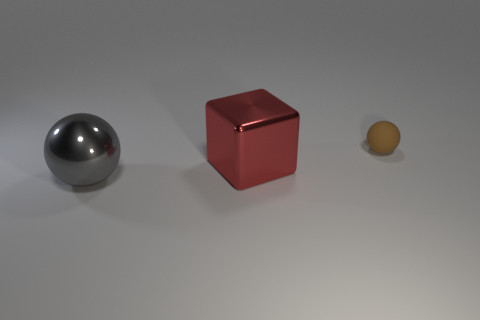Add 1 large cubes. How many objects exist? 4 Subtract all spheres. How many objects are left? 1 Add 1 red shiny things. How many red shiny things are left? 2 Add 3 brown rubber things. How many brown rubber things exist? 4 Subtract 0 yellow cubes. How many objects are left? 3 Subtract all brown rubber things. Subtract all metal cubes. How many objects are left? 1 